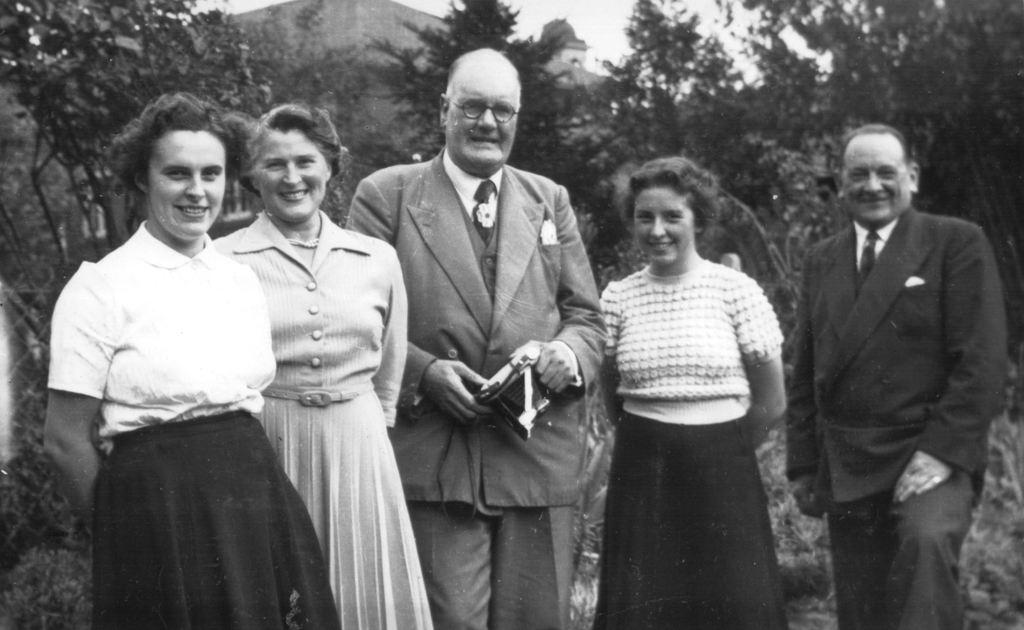How many people are in the foreground of the image? There are four people in the foreground of the image. What can be seen in the background of the image? There are trees and buildings in the background of the image. What is visible at the top of the image? The sky is visible at the top of the image. What type of beef is being served by the servant in the image? There is no beef or servant present in the image. 